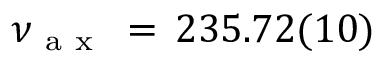<formula> <loc_0><loc_0><loc_500><loc_500>\nu _ { a x } \, = \, 2 3 5 . 7 2 ( 1 0 )</formula> 